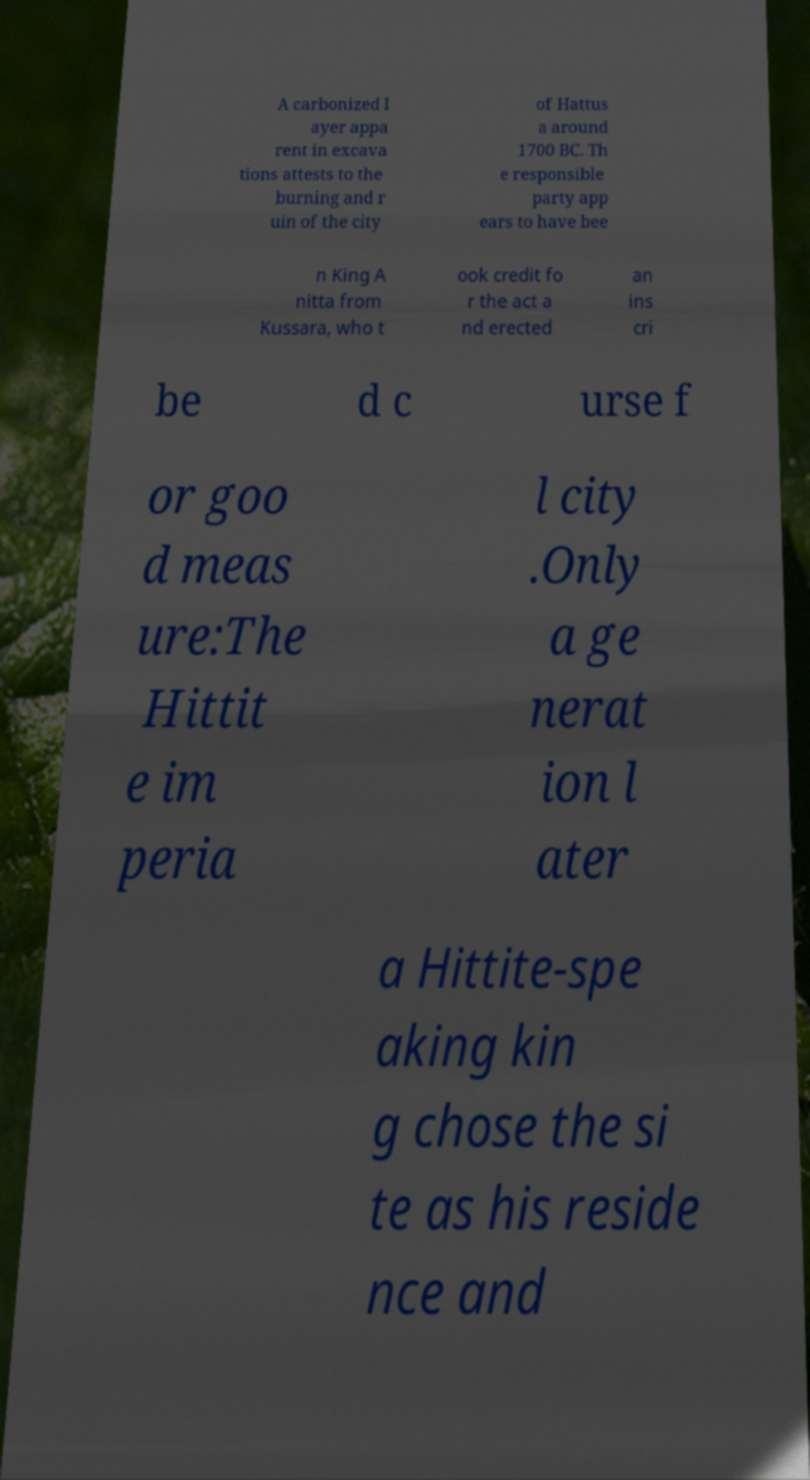I need the written content from this picture converted into text. Can you do that? A carbonized l ayer appa rent in excava tions attests to the burning and r uin of the city of Hattus a around 1700 BC. Th e responsible party app ears to have bee n King A nitta from Kussara, who t ook credit fo r the act a nd erected an ins cri be d c urse f or goo d meas ure:The Hittit e im peria l city .Only a ge nerat ion l ater a Hittite-spe aking kin g chose the si te as his reside nce and 